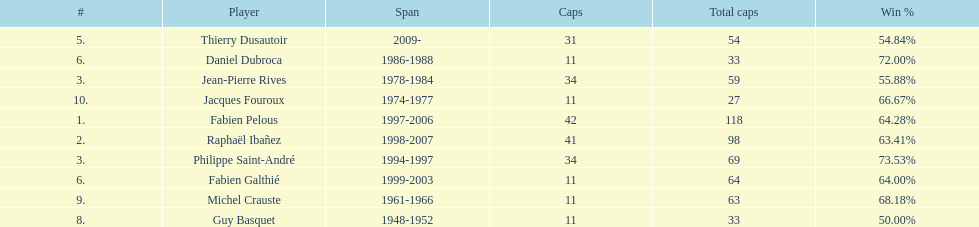How long did michel crauste serve as captain? 1961-1966. 